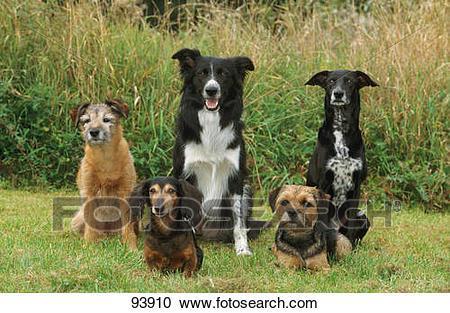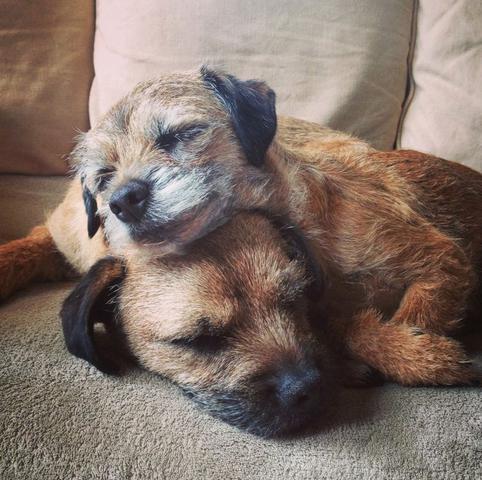The first image is the image on the left, the second image is the image on the right. Analyze the images presented: Is the assertion "Two terriers are standing in the grass with their front paws on a branch." valid? Answer yes or no. No. The first image is the image on the left, the second image is the image on the right. Given the left and right images, does the statement "At least one image shows two dogs napping together." hold true? Answer yes or no. Yes. 